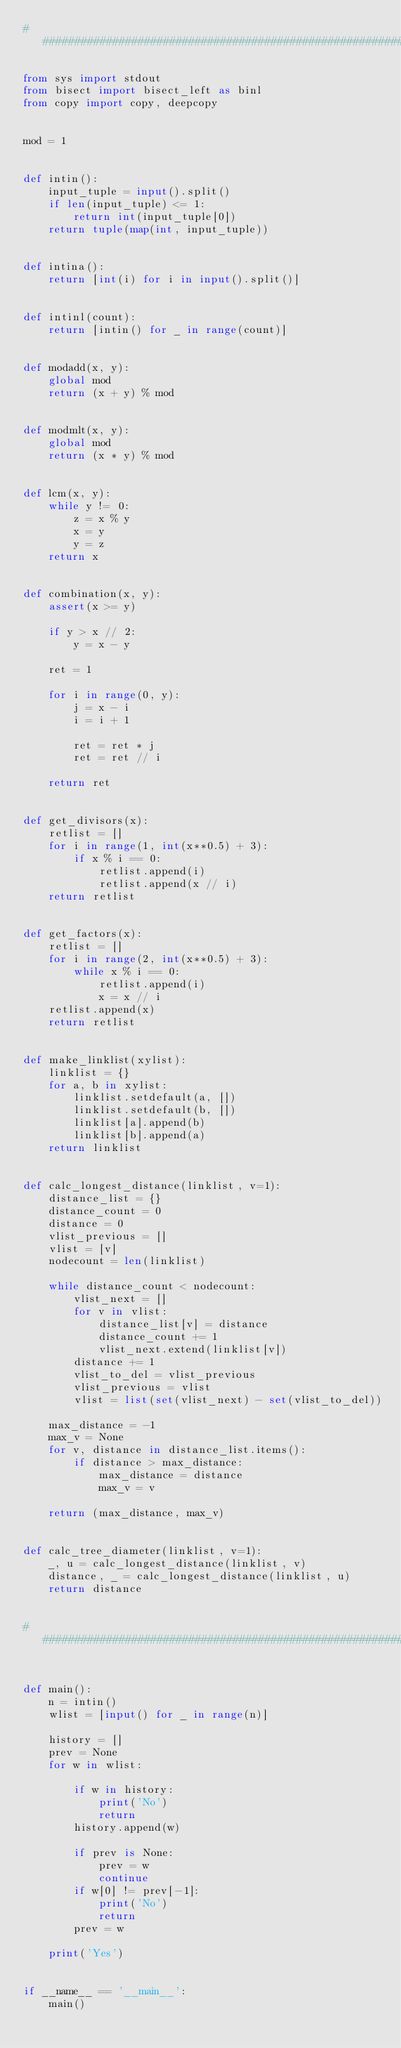Convert code to text. <code><loc_0><loc_0><loc_500><loc_500><_Python_>###############################################################################

from sys import stdout
from bisect import bisect_left as binl
from copy import copy, deepcopy


mod = 1


def intin():
    input_tuple = input().split()
    if len(input_tuple) <= 1:
        return int(input_tuple[0])
    return tuple(map(int, input_tuple))


def intina():
    return [int(i) for i in input().split()]


def intinl(count):
    return [intin() for _ in range(count)]


def modadd(x, y):
    global mod
    return (x + y) % mod


def modmlt(x, y):
    global mod
    return (x * y) % mod


def lcm(x, y):
    while y != 0:
        z = x % y
        x = y
        y = z
    return x


def combination(x, y):
    assert(x >= y)

    if y > x // 2:
        y = x - y

    ret = 1

    for i in range(0, y):
        j = x - i
        i = i + 1

        ret = ret * j
        ret = ret // i

    return ret


def get_divisors(x):
    retlist = []
    for i in range(1, int(x**0.5) + 3):
        if x % i == 0:
            retlist.append(i)
            retlist.append(x // i)
    return retlist


def get_factors(x):
    retlist = []
    for i in range(2, int(x**0.5) + 3):
        while x % i == 0:
            retlist.append(i)
            x = x // i
    retlist.append(x)
    return retlist


def make_linklist(xylist):
    linklist = {}
    for a, b in xylist:
        linklist.setdefault(a, [])
        linklist.setdefault(b, [])
        linklist[a].append(b)
        linklist[b].append(a)
    return linklist


def calc_longest_distance(linklist, v=1):
    distance_list = {}
    distance_count = 0
    distance = 0
    vlist_previous = []
    vlist = [v]
    nodecount = len(linklist)

    while distance_count < nodecount:
        vlist_next = []
        for v in vlist:
            distance_list[v] = distance
            distance_count += 1
            vlist_next.extend(linklist[v])
        distance += 1
        vlist_to_del = vlist_previous
        vlist_previous = vlist
        vlist = list(set(vlist_next) - set(vlist_to_del))

    max_distance = -1
    max_v = None
    for v, distance in distance_list.items():
        if distance > max_distance:
            max_distance = distance
            max_v = v

    return (max_distance, max_v)


def calc_tree_diameter(linklist, v=1):
    _, u = calc_longest_distance(linklist, v)
    distance, _ = calc_longest_distance(linklist, u)
    return distance


###############################################################################


def main():
    n = intin()
    wlist = [input() for _ in range(n)]

    history = []
    prev = None
    for w in wlist:

        if w in history:
            print('No')
            return
        history.append(w)

        if prev is None:
            prev = w
            continue
        if w[0] != prev[-1]:
            print('No')
            return
        prev = w

    print('Yes')


if __name__ == '__main__':
    main()
</code> 